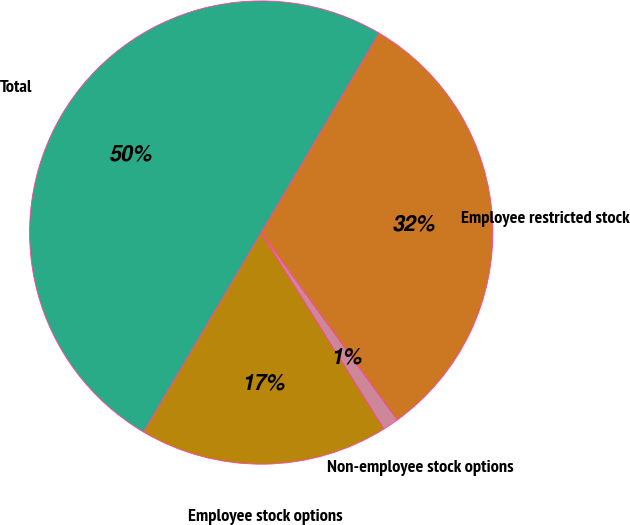Convert chart to OTSL. <chart><loc_0><loc_0><loc_500><loc_500><pie_chart><fcel>Employee stock options<fcel>Non-employee stock options<fcel>Employee restricted stock<fcel>Total<nl><fcel>17.39%<fcel>1.09%<fcel>31.52%<fcel>50.0%<nl></chart> 